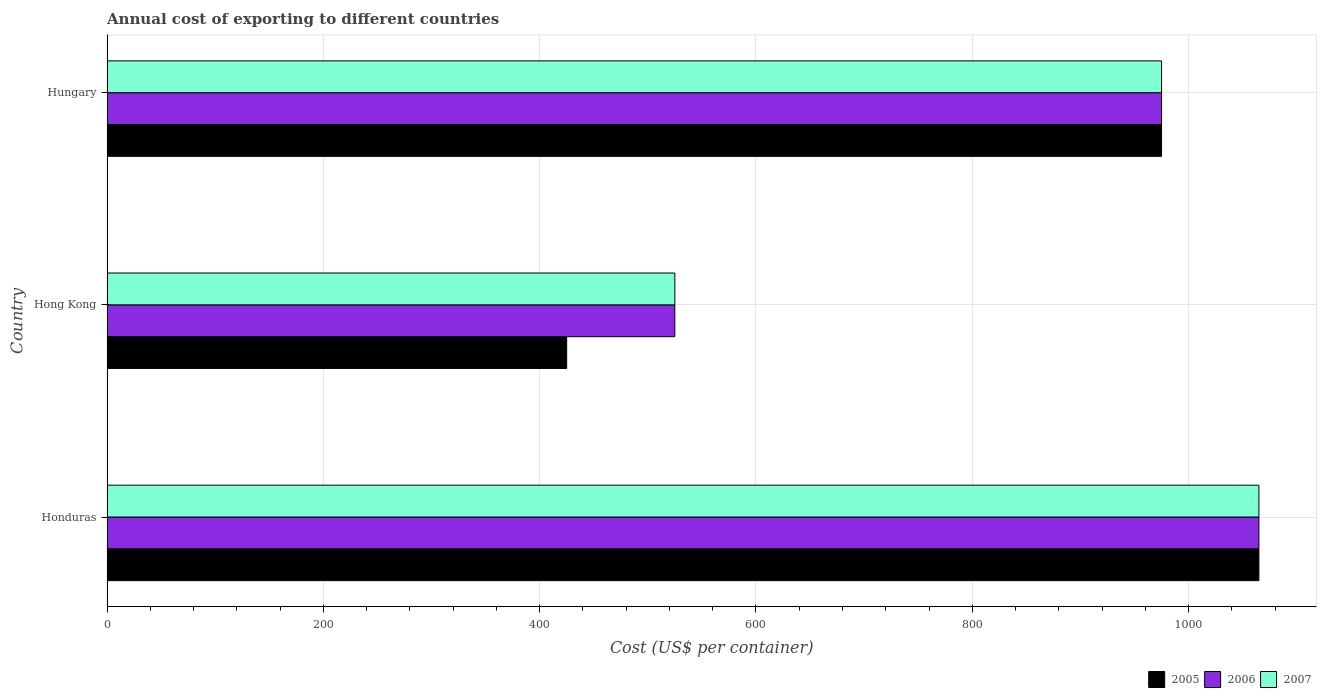How many different coloured bars are there?
Your answer should be very brief. 3. How many groups of bars are there?
Keep it short and to the point. 3. Are the number of bars per tick equal to the number of legend labels?
Your answer should be compact. Yes. How many bars are there on the 1st tick from the top?
Ensure brevity in your answer.  3. What is the label of the 1st group of bars from the top?
Your answer should be compact. Hungary. In how many cases, is the number of bars for a given country not equal to the number of legend labels?
Your answer should be very brief. 0. What is the total annual cost of exporting in 2006 in Hungary?
Ensure brevity in your answer.  975. Across all countries, what is the maximum total annual cost of exporting in 2005?
Offer a terse response. 1065. Across all countries, what is the minimum total annual cost of exporting in 2005?
Your answer should be very brief. 425. In which country was the total annual cost of exporting in 2007 maximum?
Ensure brevity in your answer.  Honduras. In which country was the total annual cost of exporting in 2007 minimum?
Make the answer very short. Hong Kong. What is the total total annual cost of exporting in 2007 in the graph?
Make the answer very short. 2565. What is the difference between the total annual cost of exporting in 2007 in Honduras and that in Hong Kong?
Ensure brevity in your answer.  540. What is the difference between the total annual cost of exporting in 2007 in Honduras and the total annual cost of exporting in 2006 in Hong Kong?
Offer a very short reply. 540. What is the average total annual cost of exporting in 2005 per country?
Your answer should be compact. 821.67. What is the difference between the total annual cost of exporting in 2005 and total annual cost of exporting in 2006 in Hungary?
Your response must be concise. 0. In how many countries, is the total annual cost of exporting in 2005 greater than 280 US$?
Make the answer very short. 3. What is the ratio of the total annual cost of exporting in 2006 in Honduras to that in Hong Kong?
Your response must be concise. 2.03. Is the total annual cost of exporting in 2007 in Hong Kong less than that in Hungary?
Keep it short and to the point. Yes. Is the difference between the total annual cost of exporting in 2005 in Hong Kong and Hungary greater than the difference between the total annual cost of exporting in 2006 in Hong Kong and Hungary?
Your answer should be very brief. No. What is the difference between the highest and the lowest total annual cost of exporting in 2005?
Your answer should be compact. 640. Is the sum of the total annual cost of exporting in 2007 in Honduras and Hong Kong greater than the maximum total annual cost of exporting in 2006 across all countries?
Make the answer very short. Yes. What does the 2nd bar from the top in Hungary represents?
Offer a very short reply. 2006. Is it the case that in every country, the sum of the total annual cost of exporting in 2005 and total annual cost of exporting in 2007 is greater than the total annual cost of exporting in 2006?
Your answer should be very brief. Yes. Does the graph contain any zero values?
Offer a terse response. No. Does the graph contain grids?
Your response must be concise. Yes. Where does the legend appear in the graph?
Offer a terse response. Bottom right. How many legend labels are there?
Your answer should be very brief. 3. How are the legend labels stacked?
Your answer should be very brief. Horizontal. What is the title of the graph?
Your answer should be very brief. Annual cost of exporting to different countries. Does "2008" appear as one of the legend labels in the graph?
Your response must be concise. No. What is the label or title of the X-axis?
Your response must be concise. Cost (US$ per container). What is the label or title of the Y-axis?
Offer a terse response. Country. What is the Cost (US$ per container) of 2005 in Honduras?
Ensure brevity in your answer.  1065. What is the Cost (US$ per container) of 2006 in Honduras?
Your answer should be compact. 1065. What is the Cost (US$ per container) of 2007 in Honduras?
Ensure brevity in your answer.  1065. What is the Cost (US$ per container) of 2005 in Hong Kong?
Your response must be concise. 425. What is the Cost (US$ per container) in 2006 in Hong Kong?
Offer a terse response. 525. What is the Cost (US$ per container) in 2007 in Hong Kong?
Offer a terse response. 525. What is the Cost (US$ per container) of 2005 in Hungary?
Give a very brief answer. 975. What is the Cost (US$ per container) in 2006 in Hungary?
Make the answer very short. 975. What is the Cost (US$ per container) of 2007 in Hungary?
Your response must be concise. 975. Across all countries, what is the maximum Cost (US$ per container) in 2005?
Provide a short and direct response. 1065. Across all countries, what is the maximum Cost (US$ per container) of 2006?
Offer a very short reply. 1065. Across all countries, what is the maximum Cost (US$ per container) in 2007?
Offer a very short reply. 1065. Across all countries, what is the minimum Cost (US$ per container) in 2005?
Make the answer very short. 425. Across all countries, what is the minimum Cost (US$ per container) in 2006?
Your answer should be compact. 525. Across all countries, what is the minimum Cost (US$ per container) in 2007?
Give a very brief answer. 525. What is the total Cost (US$ per container) in 2005 in the graph?
Your response must be concise. 2465. What is the total Cost (US$ per container) of 2006 in the graph?
Offer a very short reply. 2565. What is the total Cost (US$ per container) of 2007 in the graph?
Your response must be concise. 2565. What is the difference between the Cost (US$ per container) of 2005 in Honduras and that in Hong Kong?
Give a very brief answer. 640. What is the difference between the Cost (US$ per container) in 2006 in Honduras and that in Hong Kong?
Your answer should be very brief. 540. What is the difference between the Cost (US$ per container) of 2007 in Honduras and that in Hong Kong?
Offer a terse response. 540. What is the difference between the Cost (US$ per container) in 2005 in Honduras and that in Hungary?
Make the answer very short. 90. What is the difference between the Cost (US$ per container) in 2007 in Honduras and that in Hungary?
Make the answer very short. 90. What is the difference between the Cost (US$ per container) in 2005 in Hong Kong and that in Hungary?
Ensure brevity in your answer.  -550. What is the difference between the Cost (US$ per container) in 2006 in Hong Kong and that in Hungary?
Your answer should be very brief. -450. What is the difference between the Cost (US$ per container) of 2007 in Hong Kong and that in Hungary?
Your response must be concise. -450. What is the difference between the Cost (US$ per container) in 2005 in Honduras and the Cost (US$ per container) in 2006 in Hong Kong?
Make the answer very short. 540. What is the difference between the Cost (US$ per container) in 2005 in Honduras and the Cost (US$ per container) in 2007 in Hong Kong?
Offer a terse response. 540. What is the difference between the Cost (US$ per container) in 2006 in Honduras and the Cost (US$ per container) in 2007 in Hong Kong?
Offer a terse response. 540. What is the difference between the Cost (US$ per container) of 2005 in Honduras and the Cost (US$ per container) of 2006 in Hungary?
Offer a very short reply. 90. What is the difference between the Cost (US$ per container) of 2005 in Hong Kong and the Cost (US$ per container) of 2006 in Hungary?
Provide a succinct answer. -550. What is the difference between the Cost (US$ per container) in 2005 in Hong Kong and the Cost (US$ per container) in 2007 in Hungary?
Keep it short and to the point. -550. What is the difference between the Cost (US$ per container) of 2006 in Hong Kong and the Cost (US$ per container) of 2007 in Hungary?
Give a very brief answer. -450. What is the average Cost (US$ per container) of 2005 per country?
Offer a terse response. 821.67. What is the average Cost (US$ per container) of 2006 per country?
Ensure brevity in your answer.  855. What is the average Cost (US$ per container) of 2007 per country?
Your answer should be compact. 855. What is the difference between the Cost (US$ per container) in 2005 and Cost (US$ per container) in 2006 in Honduras?
Your answer should be very brief. 0. What is the difference between the Cost (US$ per container) in 2005 and Cost (US$ per container) in 2007 in Honduras?
Provide a succinct answer. 0. What is the difference between the Cost (US$ per container) in 2006 and Cost (US$ per container) in 2007 in Honduras?
Keep it short and to the point. 0. What is the difference between the Cost (US$ per container) of 2005 and Cost (US$ per container) of 2006 in Hong Kong?
Provide a short and direct response. -100. What is the difference between the Cost (US$ per container) in 2005 and Cost (US$ per container) in 2007 in Hong Kong?
Offer a terse response. -100. What is the difference between the Cost (US$ per container) of 2006 and Cost (US$ per container) of 2007 in Hong Kong?
Make the answer very short. 0. What is the ratio of the Cost (US$ per container) of 2005 in Honduras to that in Hong Kong?
Your response must be concise. 2.51. What is the ratio of the Cost (US$ per container) of 2006 in Honduras to that in Hong Kong?
Your response must be concise. 2.03. What is the ratio of the Cost (US$ per container) in 2007 in Honduras to that in Hong Kong?
Offer a terse response. 2.03. What is the ratio of the Cost (US$ per container) of 2005 in Honduras to that in Hungary?
Keep it short and to the point. 1.09. What is the ratio of the Cost (US$ per container) of 2006 in Honduras to that in Hungary?
Your response must be concise. 1.09. What is the ratio of the Cost (US$ per container) of 2007 in Honduras to that in Hungary?
Provide a succinct answer. 1.09. What is the ratio of the Cost (US$ per container) of 2005 in Hong Kong to that in Hungary?
Your answer should be very brief. 0.44. What is the ratio of the Cost (US$ per container) in 2006 in Hong Kong to that in Hungary?
Provide a succinct answer. 0.54. What is the ratio of the Cost (US$ per container) in 2007 in Hong Kong to that in Hungary?
Offer a terse response. 0.54. What is the difference between the highest and the lowest Cost (US$ per container) of 2005?
Your answer should be compact. 640. What is the difference between the highest and the lowest Cost (US$ per container) in 2006?
Offer a terse response. 540. What is the difference between the highest and the lowest Cost (US$ per container) in 2007?
Give a very brief answer. 540. 